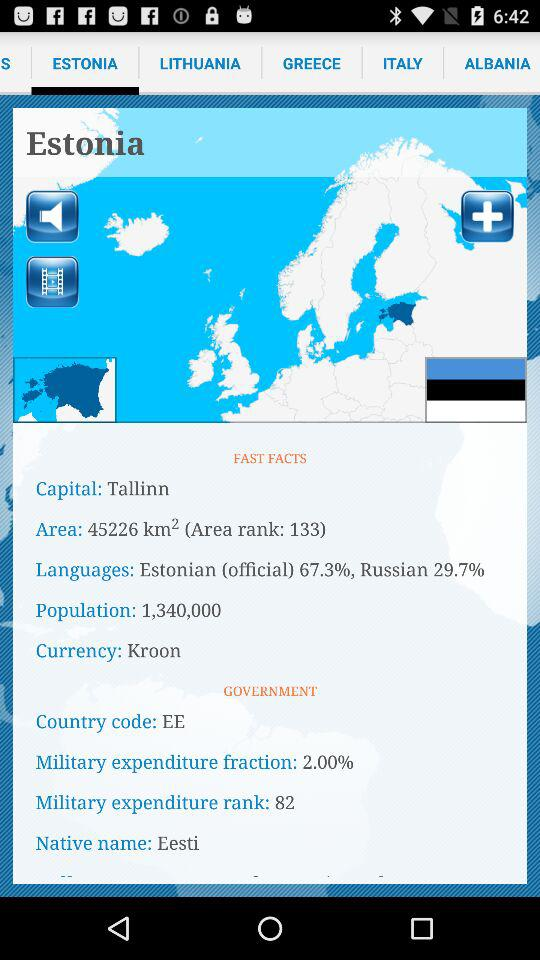What is the area of the selected country? The area is 45226 km². 